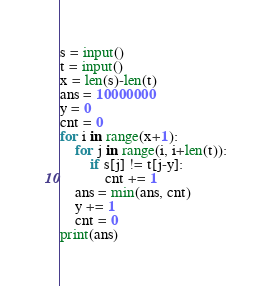Convert code to text. <code><loc_0><loc_0><loc_500><loc_500><_Python_>s = input()
t = input()
x = len(s)-len(t)
ans = 10000000
y = 0
cnt = 0
for i in range(x+1):
    for j in range(i, i+len(t)):
        if s[j] != t[j-y]:
            cnt += 1
    ans = min(ans, cnt)
    y += 1
    cnt = 0
print(ans)</code> 